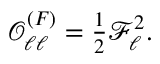<formula> <loc_0><loc_0><loc_500><loc_500>\begin{array} { r } { \mathcal { O } _ { \ell \ell } ^ { ( F ) } = \frac { 1 } { 2 } \mathcal { F } _ { \ell } ^ { 2 } . } \end{array}</formula> 